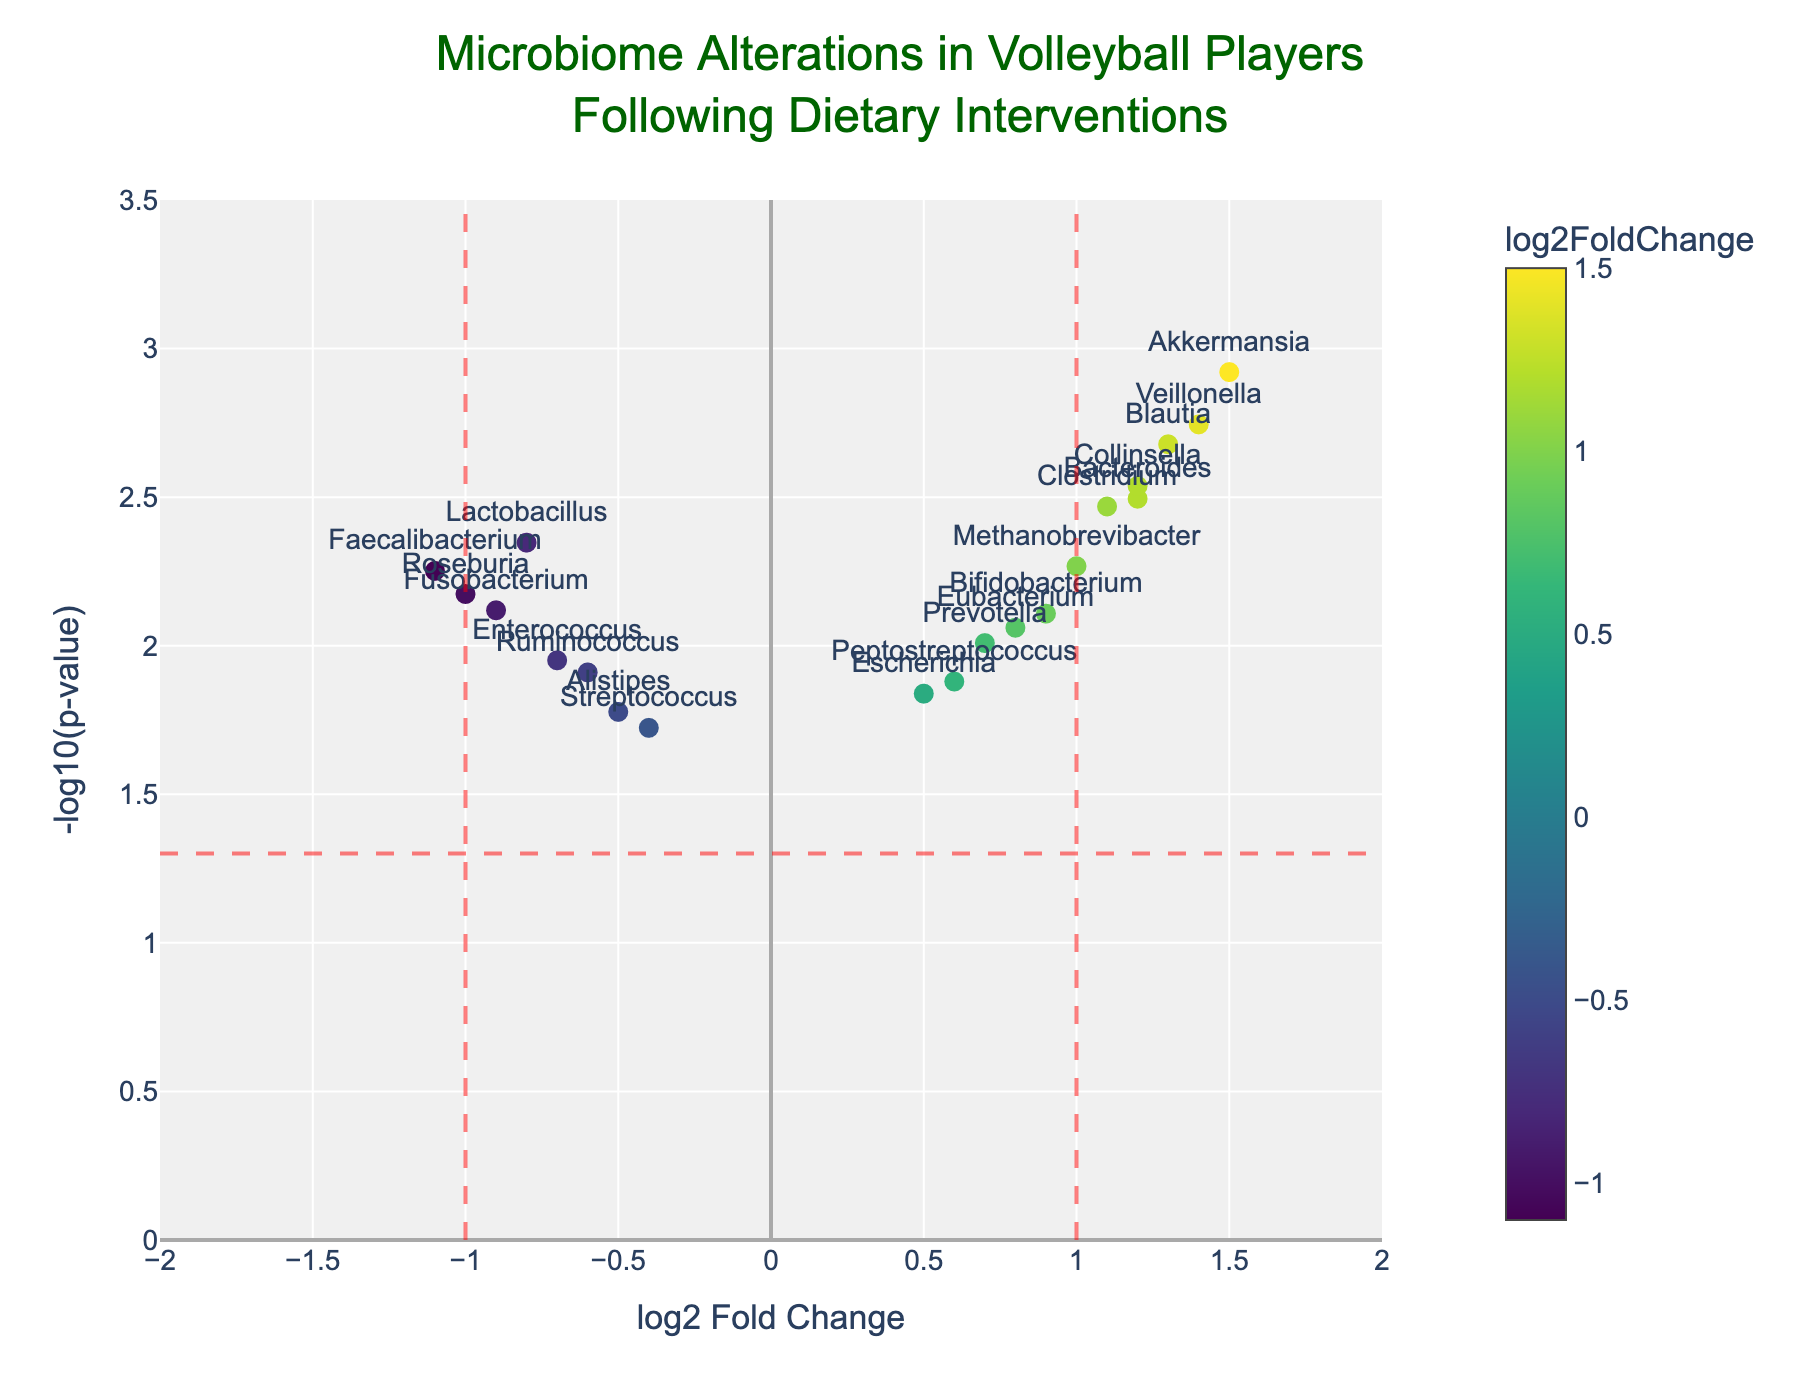What is the title of the figure? The title is located at the top of the figure within the title section and often summarizes the main focus of the plot.
Answer: Microbiome Alterations in Volleyball Players Following Dietary Interventions What are the axes labels in the plot? The axes labels are typically visible along the x-axis and y-axis. In this plot, the x-axis label indicates the metric of the fold change, while the y-axis label shows the significance metric.
Answer: log2 Fold Change and -log10(p-value) How many genes have a log2 fold change greater than 1? Identify points on the x-axis that are greater than 1 and count them. These would be the points to the right of the red vertical line at x = 1.
Answer: 4 genes Which gene has the smallest p-value and what is its log2 fold change? The smallest p-value corresponds to the point with the highest y-value (-log10(p-value)). The gene can be identified through the text label nearest to this point.
Answer: Akkermansia, 1.5 Which gene shows the largest decrease in log2 fold change? The largest decrease in log2 fold change is represented by the data point furthest to the left in the negative direction on the x-axis. Locate this point and read the gene label.
Answer: Faecalibacterium What is the range of the y-axis in the plot? Check the y-axis markings from the bottom to the top to determine the range.
Answer: 0 to 3.5 How many genes are shown in the plot overall? Count all the data points in the plot, which correspond to the rows of data provided.
Answer: 19 genes Which genes are highlighted due to having a significant p-value (below 0.05) and a log2 fold change above 1? For significance, y-values should be higher than the horizontal red line at -log10(0.05) (~1.301). Also, check that x-values are above 1. Identify the text labels of these points.
Answer: Akkermansia, Blautia, Veillonella What can be inferred about the genes with a log2 fold change less than -1? Identify the data points left of the red vertical line at x = -1. These points exhibit significant negative fold changes. Identify these genes.
Answer: Faecalibacterium, Roseburia What is the relationship between log2 fold change and -log10(p-value) for the gene Bacteroides? Find the specific values for Bacteroides in the data. Bacteroides has a positive log2 fold change and a negative log10(p-value), indicating higher abundance with a significant p-value.
Answer: log2 Fold Change: 1.2, -log10(p-value): 2.495 